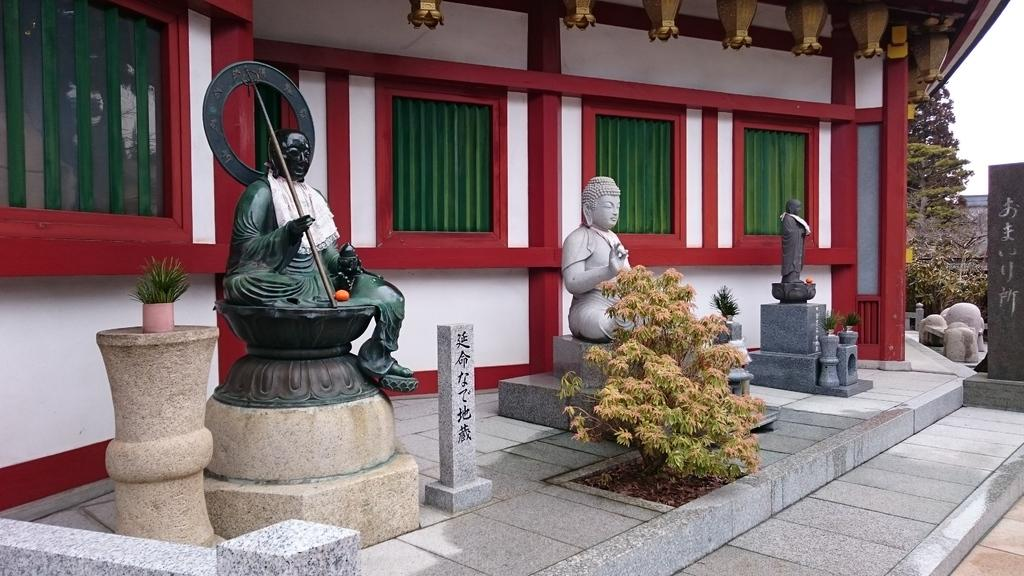What type of objects can be seen in the image? There are statues in the image. What else can be seen in the image besides the statues? There are plants and a building visible in the image. What can be seen in the background of the image? There are trees in the background of the image. Can you tell me how many bikes are parked near the statues in the image? There are no bikes present in the image; it features statues, plants, and a building. What type of farm animals can be seen grazing near the trees in the background? There are no farm animals present in the image; it only features trees in the background. 